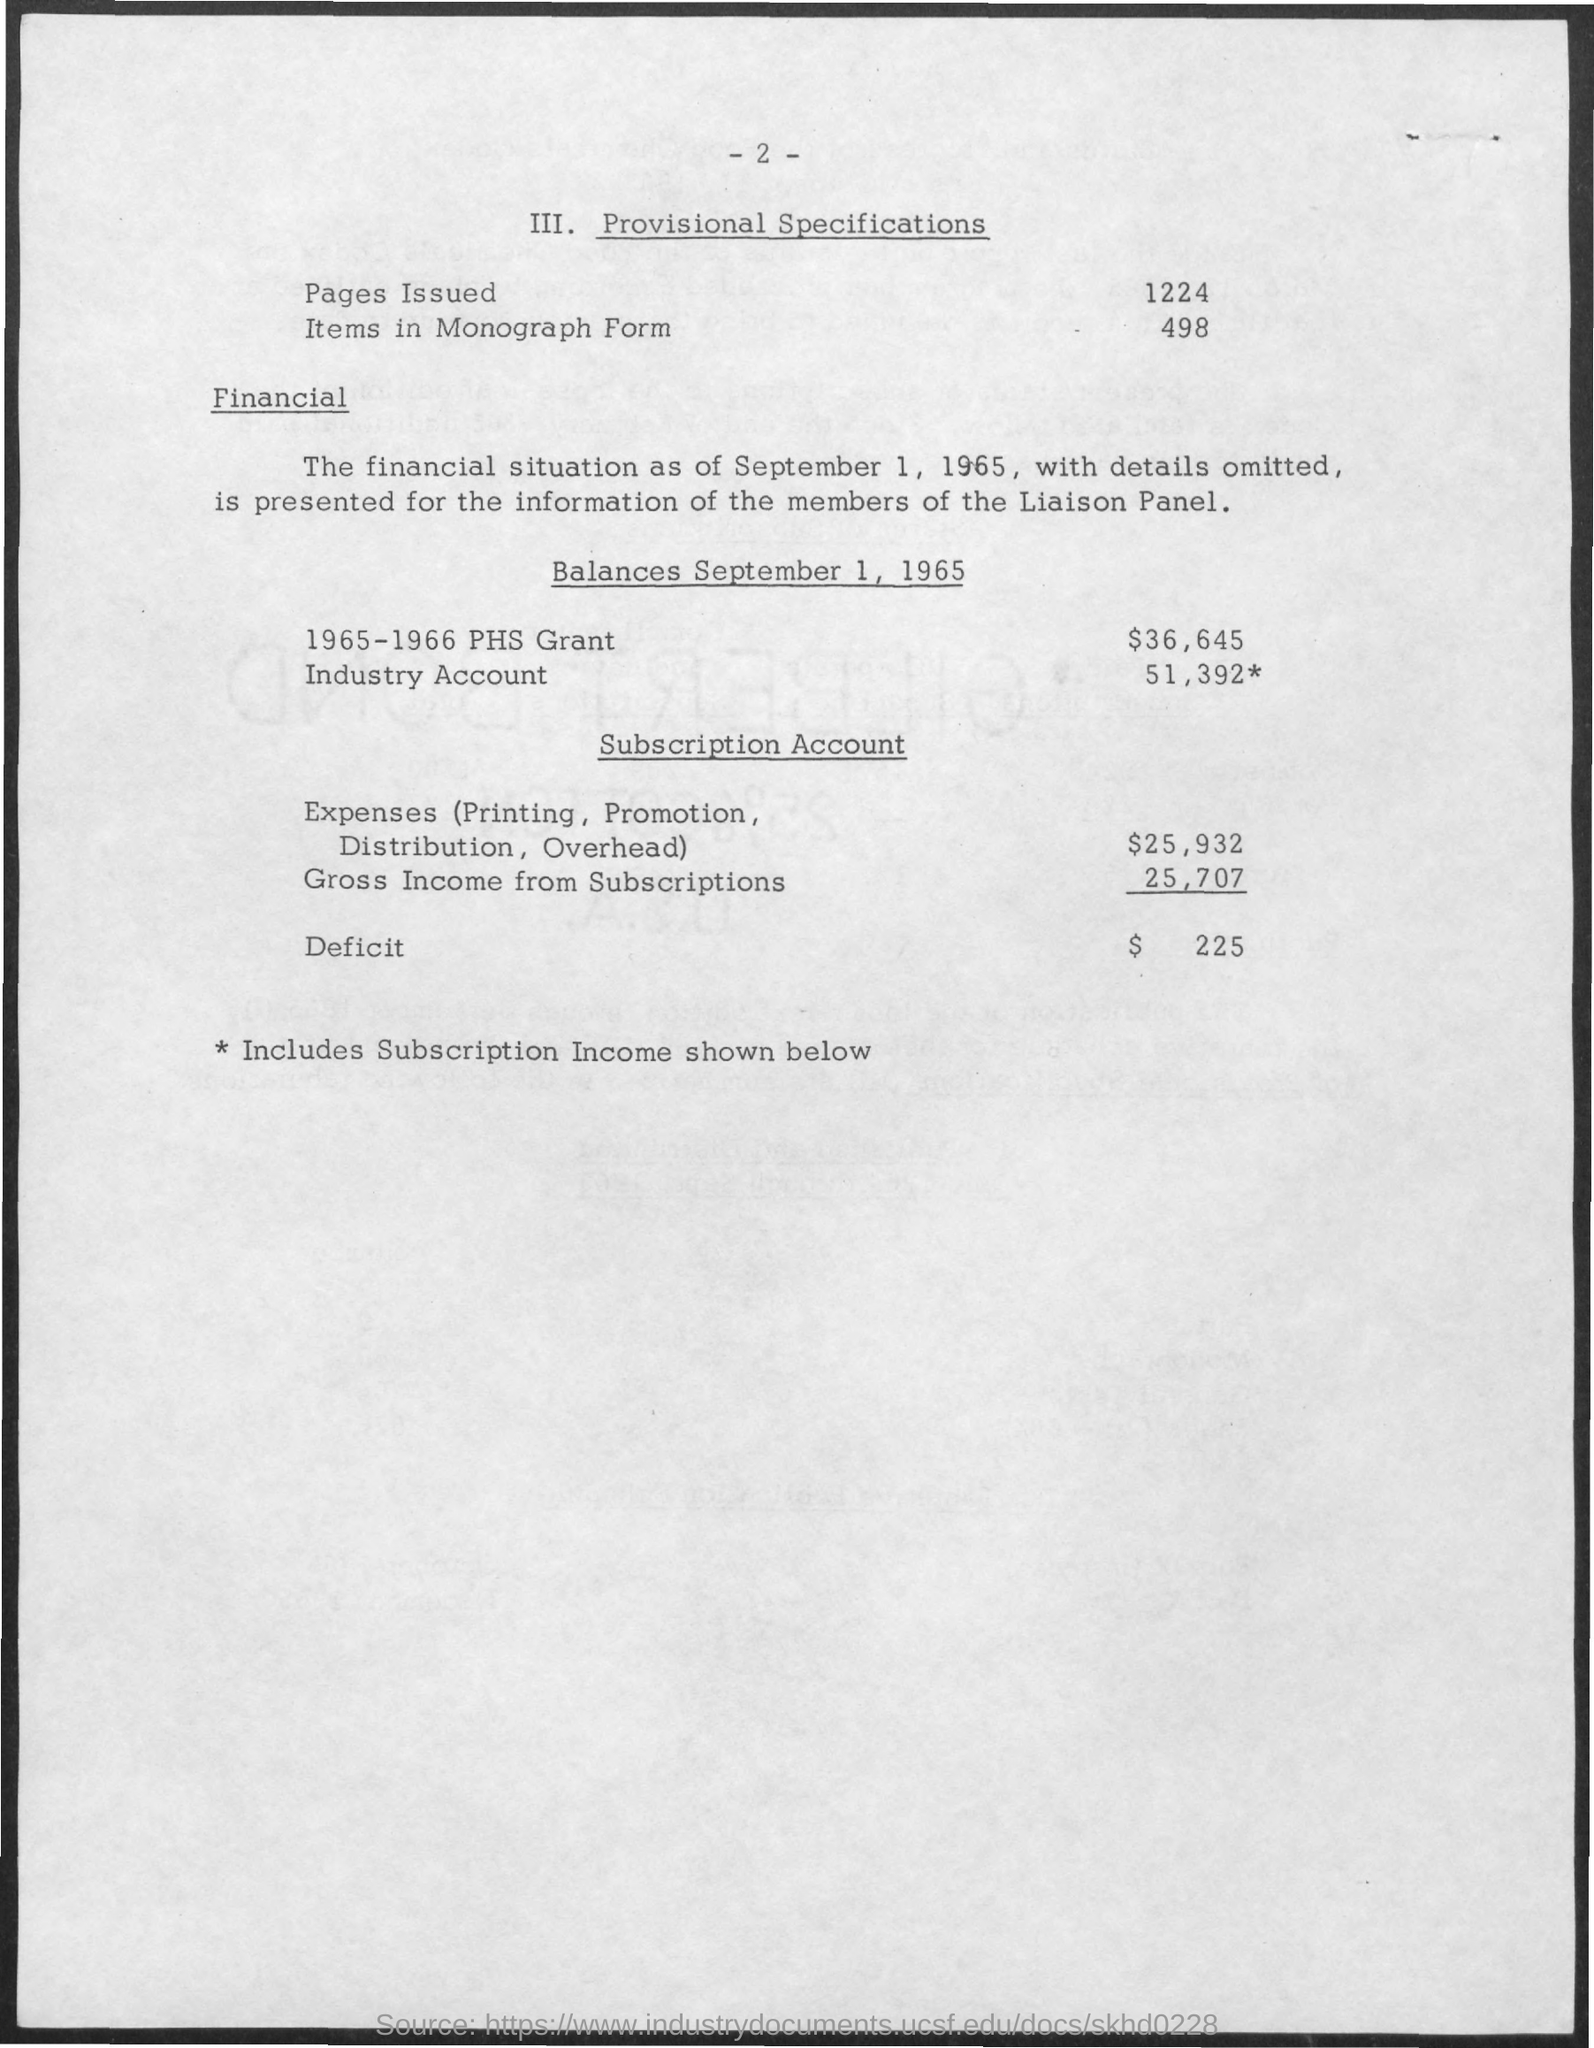Mention a couple of crucial points in this snapshot. There are 1224 pages issued. The balance for the 1965-1966 PHS Grant as of September 1, 1965 was $36,645. The deficit is $225. The Subscription Account for Expenses, including Printing, Promotion, Distribution, and Overhead, is $25,932. There are 498 items in monograph form. 